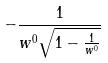<formula> <loc_0><loc_0><loc_500><loc_500>- \frac { 1 } { w ^ { 0 } \sqrt { 1 - \frac { 1 } { w ^ { 0 } } } }</formula> 